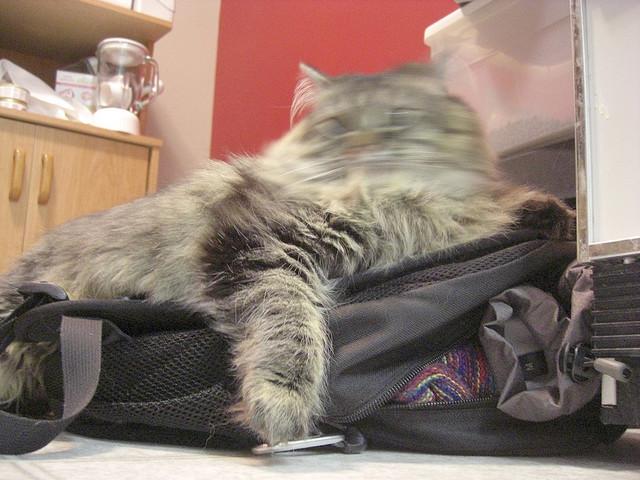What is the cat sitting on?
Write a very short answer. Backpack. What appliance is on the counter?
Answer briefly. Blender. What is the cat lying on?
Give a very brief answer. Backpack. Does the cat look playful?
Quick response, please. Yes. What appliance is behind the cat?
Concise answer only. Blender. What is the cat sitting inside of?
Write a very short answer. Bag. Why is the cat's face blurred?
Write a very short answer. Its moving. 